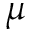<formula> <loc_0><loc_0><loc_500><loc_500>\mu</formula> 